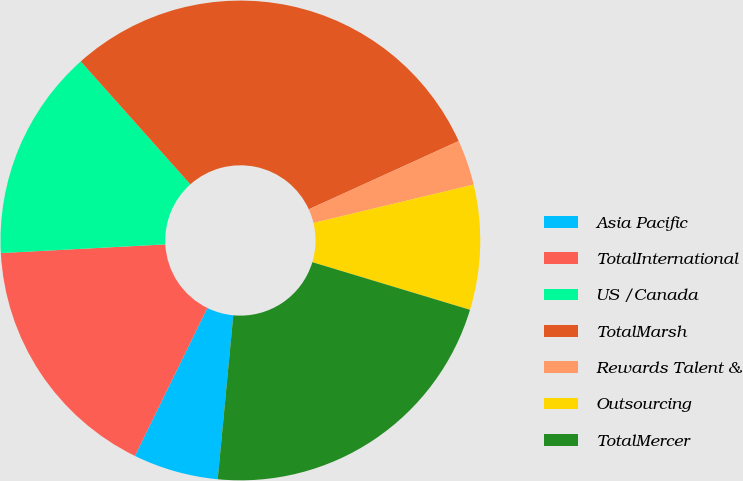<chart> <loc_0><loc_0><loc_500><loc_500><pie_chart><fcel>Asia Pacific<fcel>TotalInternational<fcel>US /Canada<fcel>TotalMarsh<fcel>Rewards Talent &<fcel>Outsourcing<fcel>TotalMercer<nl><fcel>5.74%<fcel>16.92%<fcel>14.25%<fcel>29.79%<fcel>3.06%<fcel>8.41%<fcel>21.84%<nl></chart> 